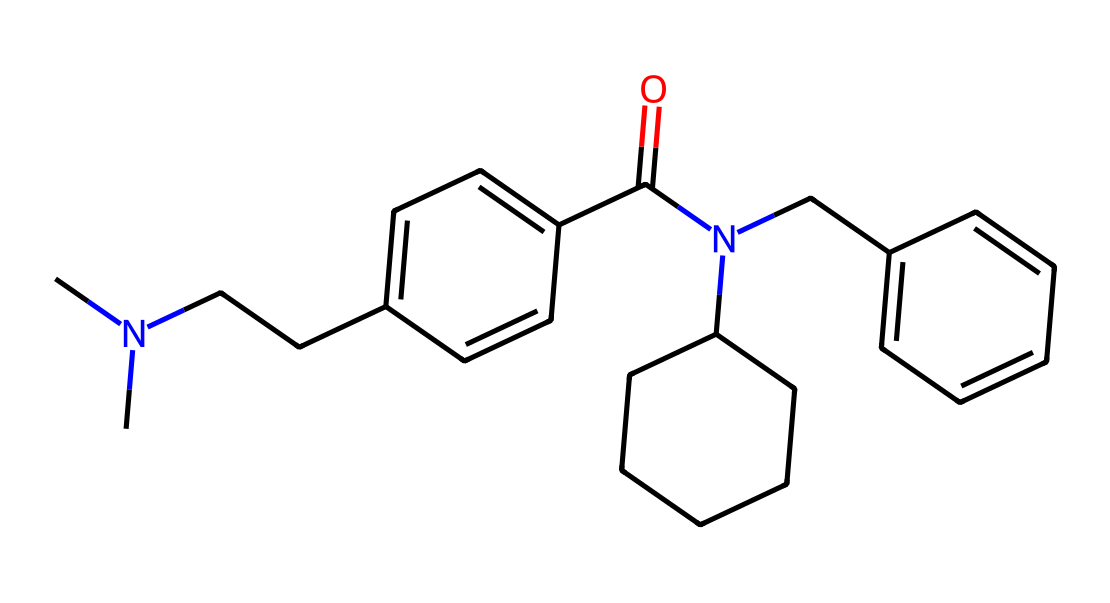What is the molecular formula of fentanyl? To determine the molecular formula, count the number of carbon, hydrogen, nitrogen, and oxygen atoms in the SMILES representation. The SMILES indicates a molecule with 22 carbons, 28 hydrogens, 2 nitrogens, and 1 oxygen, leading to the formula C22H28N2O.
Answer: C22H28N2O How many rings are present in fentanyl? The visual structure of the chemical highlights two distinct cycloalkane rings. Thus, by identifying and counting these rings, we conclude that there are 2 rings in the structure.
Answer: 2 What is the primary functional group in fentanyl? Examining the structure reveals an amide functional group characterized by a nitrogen atom directly bonded to a carbonyl (C=O). This identification points out the presence of an amide moiety, typical for fentanyl derivatives.
Answer: amide What type of drug is fentanyl categorized as? Fentanyl is classified as a synthetic opioid based on its structure, which includes the nitrogen atom typical of opioids and its analgesic properties. Thus, from both structure and function, it's identified as an opioid drug.
Answer: opioid What is the characteristic feature of fentanyl that enhances its potency? The presence of multiple aromatic rings and the specific arrangement of nitrogen atoms in the structure contributes to its high potency compared to morphine, effectively making it one of the strongest opioids available.
Answer: high potency 